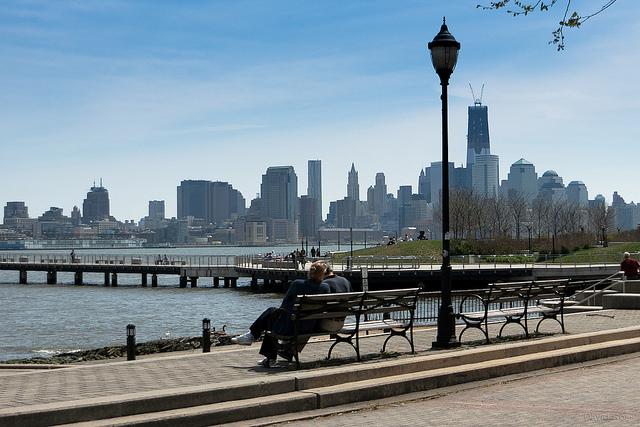How many benches are there?
Write a very short answer. 2. What is the black-and-white striped object near the left of the picture?
Answer briefly. Bridge. Are there any umbrellas next to the river?
Answer briefly. No. What is the tallest antenna used for?
Concise answer only. Lights. How is the picture?
Give a very brief answer. Clear. Is there an Esplanade?
Short answer required. Yes. Is this a big city?
Answer briefly. Yes. 